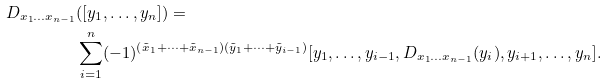Convert formula to latex. <formula><loc_0><loc_0><loc_500><loc_500>D _ { x _ { 1 } \dots x _ { n - 1 } } & ( [ y _ { 1 } , \dots , y _ { n } ] ) = \\ & \sum _ { i = 1 } ^ { n } ( - 1 ) ^ { ( { \tilde { x } } _ { 1 } + \dots + { \tilde { x } } _ { n - 1 } ) ( { \tilde { y } } _ { 1 } + \dots + { \tilde { y } } _ { i - 1 } ) } [ y _ { 1 } , \dots , y _ { i - 1 } , D _ { x _ { 1 } \dots x _ { n - 1 } } ( y _ { i } ) , y _ { i + 1 } , \dots , y _ { n } ] .</formula> 